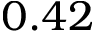Convert formula to latex. <formula><loc_0><loc_0><loc_500><loc_500>0 . 4 2</formula> 